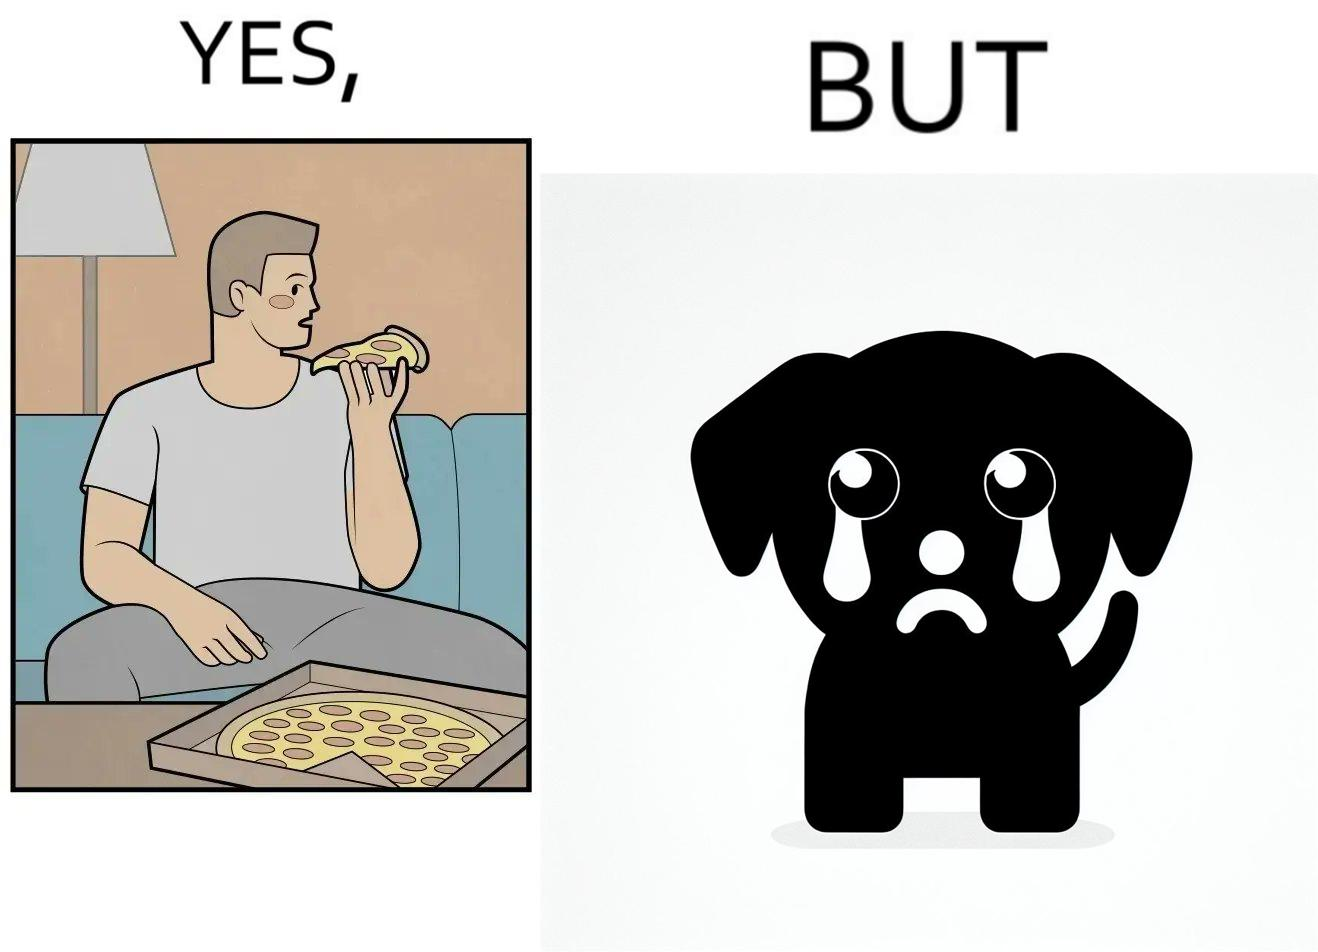What makes this image funny or satirical? The images are funny since they show how pet owners cannot enjoy any tasty food like pizza without sharing with their pets. The look from the pets makes the owner too guilty if he does not share his food 